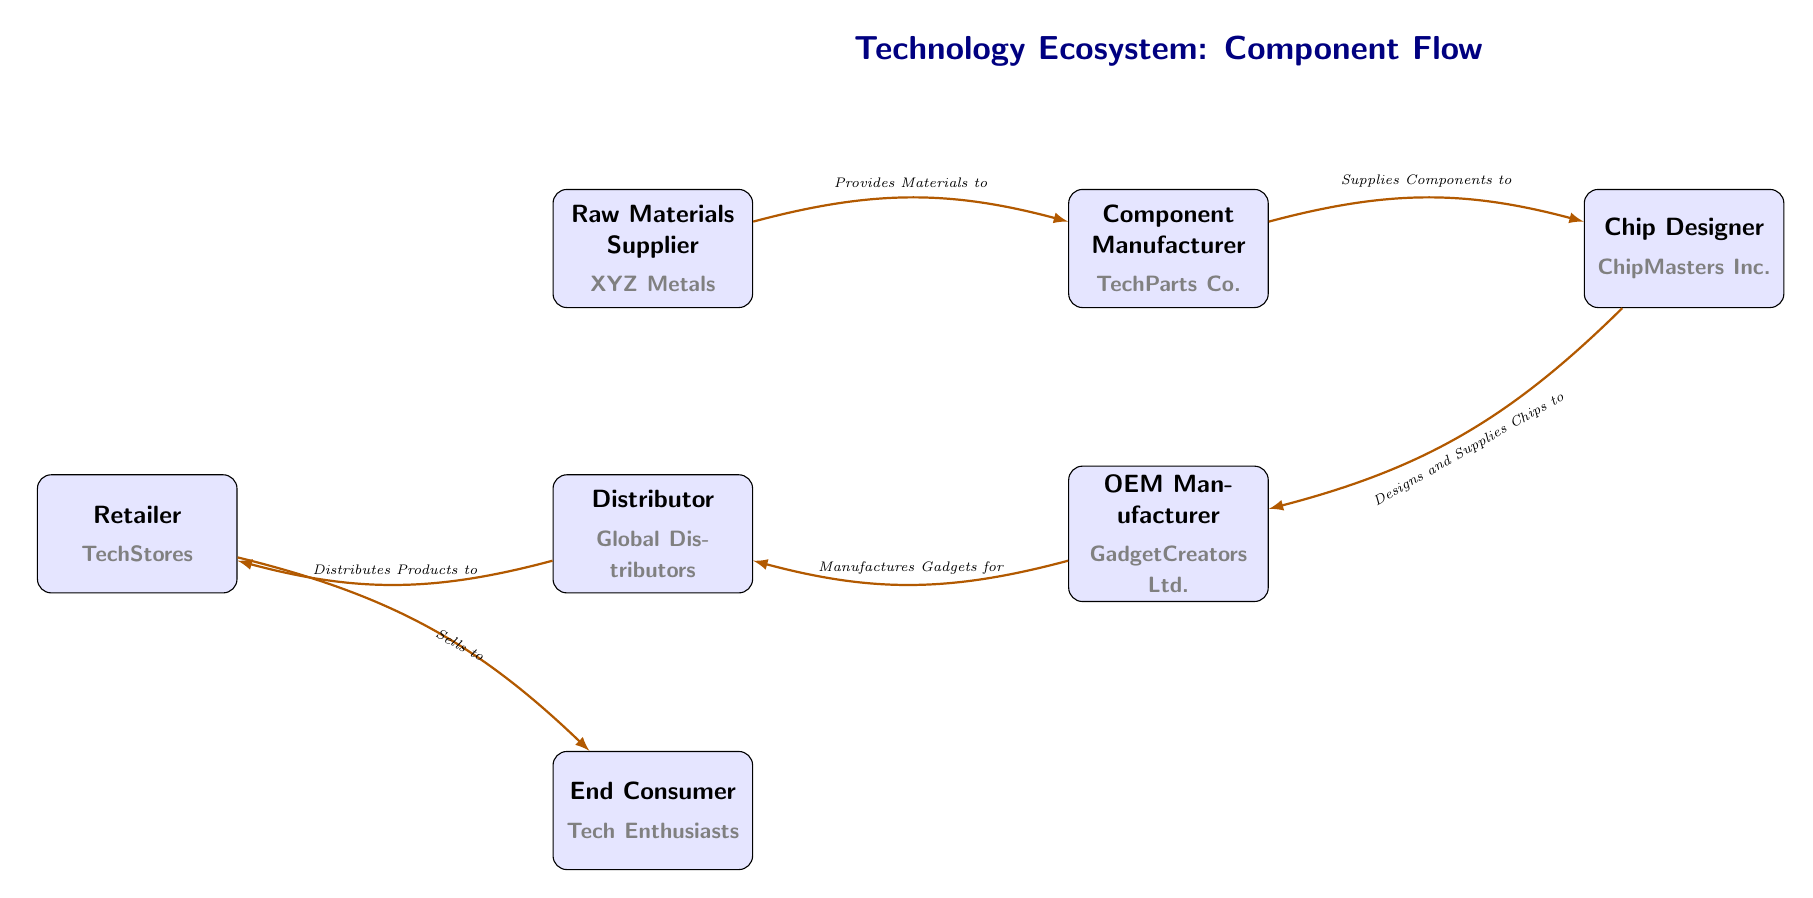What is the first node in the food chain? The first node represents the Raw Materials Supplier, which is positioned at the leftmost part of the diagram.
Answer: Raw Materials Supplier Who is responsible for designing and supplying chips? The node that fulfills this role is the Chip Designer, located to the right of the Component Manufacturer in the flow of the diagram.
Answer: Chip Designer How many nodes are in the diagram? By counting each named entity in the diagram, we identify a total of 7 distinct nodes, starting from the Raw Materials Supplier to the End Consumer.
Answer: 7 What role does the OEM Manufacturer have in the flow? The OEM Manufacturer's role is indicated by the arrow directed from it to the Distributor, where it manufactures gadgets for distribution.
Answer: Manufactures Gadgets Which supplier directly provides materials to the Component Manufacturer? The arrow shows that the Raw Materials Supplier is the direct provider of materials to the Component Manufacturer, indicating a one-to-one relationship.
Answer: Raw Materials Supplier What is the relationship between the Distributor and the Retailer? The Distributor supplies products to the Retailer, evidenced by the arrow flowing from the Distributor to the Retailer node in the diagram.
Answer: Distributes Products How many edges are in the diagram? Each connection between nodes represents an edge, and by analyzing the diagram, we find there are 6 edges showing the relationships between nodes.
Answer: 6 Who sells to the end consumer? According to the flow, it is the Retailer who sells products to the End Consumer, depicted by the arrow directed from the Retailer to the End Consumer node.
Answer: Retailer What role does Global Distributors play? The diagram shows that Global Distributors act as the Distributor in the technology ecosystem, indicating their position in the supply chain.
Answer: Distributor 